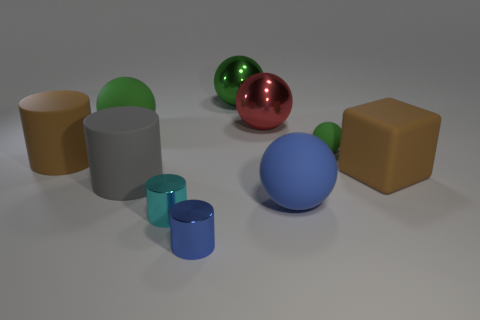Are there fewer red metal balls than green balls?
Your answer should be very brief. Yes. What is the size of the matte thing that is both on the left side of the large green metallic object and in front of the matte cube?
Your answer should be compact. Large. What is the size of the cyan cylinder that is in front of the ball in front of the big brown rubber object that is left of the tiny green sphere?
Make the answer very short. Small. How big is the cyan object?
Your response must be concise. Small. There is a brown matte thing that is to the right of the green ball left of the small cyan cylinder; is there a large brown thing behind it?
Offer a very short reply. Yes. What number of small things are red rubber cylinders or blue rubber things?
Your answer should be very brief. 0. Do the green thing that is behind the red ball and the cyan metallic thing have the same size?
Provide a succinct answer. No. The big rubber ball that is on the right side of the big shiny sphere on the right side of the metallic sphere left of the large red metallic ball is what color?
Offer a terse response. Blue. The matte block has what color?
Ensure brevity in your answer.  Brown. Does the large brown object left of the tiny cyan thing have the same material as the blue thing that is right of the small blue cylinder?
Provide a succinct answer. Yes. 